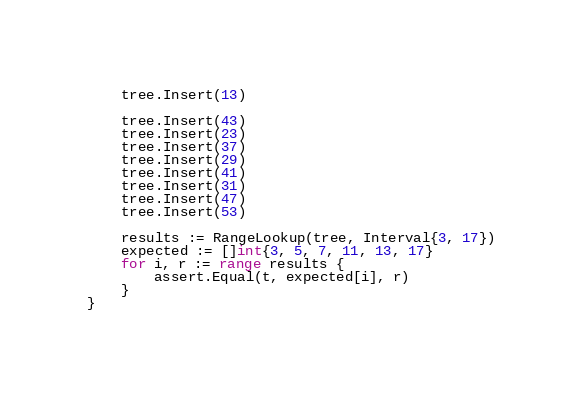Convert code to text. <code><loc_0><loc_0><loc_500><loc_500><_Go_>	tree.Insert(13)

	tree.Insert(43)
	tree.Insert(23)
	tree.Insert(37)
	tree.Insert(29)
	tree.Insert(41)
	tree.Insert(31)
	tree.Insert(47)
	tree.Insert(53)

	results := RangeLookup(tree, Interval{3, 17})
	expected := []int{3, 5, 7, 11, 13, 17}
	for i, r := range results {
		assert.Equal(t, expected[i], r)
	}
}
</code> 